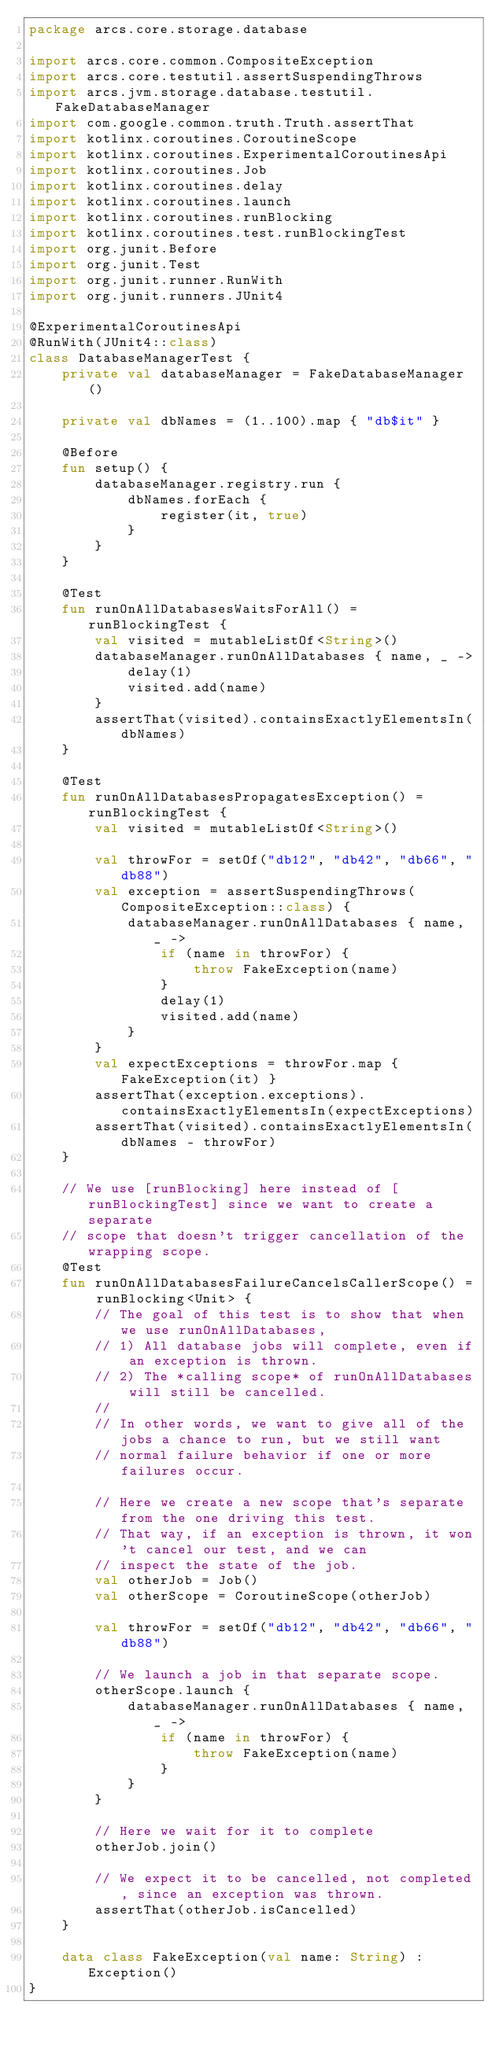<code> <loc_0><loc_0><loc_500><loc_500><_Kotlin_>package arcs.core.storage.database

import arcs.core.common.CompositeException
import arcs.core.testutil.assertSuspendingThrows
import arcs.jvm.storage.database.testutil.FakeDatabaseManager
import com.google.common.truth.Truth.assertThat
import kotlinx.coroutines.CoroutineScope
import kotlinx.coroutines.ExperimentalCoroutinesApi
import kotlinx.coroutines.Job
import kotlinx.coroutines.delay
import kotlinx.coroutines.launch
import kotlinx.coroutines.runBlocking
import kotlinx.coroutines.test.runBlockingTest
import org.junit.Before
import org.junit.Test
import org.junit.runner.RunWith
import org.junit.runners.JUnit4

@ExperimentalCoroutinesApi
@RunWith(JUnit4::class)
class DatabaseManagerTest {
    private val databaseManager = FakeDatabaseManager()

    private val dbNames = (1..100).map { "db$it" }

    @Before
    fun setup() {
        databaseManager.registry.run {
            dbNames.forEach {
                register(it, true)
            }
        }
    }

    @Test
    fun runOnAllDatabasesWaitsForAll() = runBlockingTest {
        val visited = mutableListOf<String>()
        databaseManager.runOnAllDatabases { name, _ ->
            delay(1)
            visited.add(name)
        }
        assertThat(visited).containsExactlyElementsIn(dbNames)
    }

    @Test
    fun runOnAllDatabasesPropagatesException() = runBlockingTest {
        val visited = mutableListOf<String>()

        val throwFor = setOf("db12", "db42", "db66", "db88")
        val exception = assertSuspendingThrows(CompositeException::class) {
            databaseManager.runOnAllDatabases { name, _ ->
                if (name in throwFor) {
                    throw FakeException(name)
                }
                delay(1)
                visited.add(name)
            }
        }
        val expectExceptions = throwFor.map { FakeException(it) }
        assertThat(exception.exceptions).containsExactlyElementsIn(expectExceptions)
        assertThat(visited).containsExactlyElementsIn(dbNames - throwFor)
    }

    // We use [runBlocking] here instead of [runBlockingTest] since we want to create a separate
    // scope that doesn't trigger cancellation of the wrapping scope.
    @Test
    fun runOnAllDatabasesFailureCancelsCallerScope() = runBlocking<Unit> {
        // The goal of this test is to show that when we use runOnAllDatabases,
        // 1) All database jobs will complete, even if an exception is thrown.
        // 2) The *calling scope* of runOnAllDatabases will still be cancelled.
        //
        // In other words, we want to give all of the jobs a chance to run, but we still want
        // normal failure behavior if one or more failures occur.

        // Here we create a new scope that's separate from the one driving this test.
        // That way, if an exception is thrown, it won't cancel our test, and we can
        // inspect the state of the job.
        val otherJob = Job()
        val otherScope = CoroutineScope(otherJob)

        val throwFor = setOf("db12", "db42", "db66", "db88")

        // We launch a job in that separate scope.
        otherScope.launch {
            databaseManager.runOnAllDatabases { name, _ ->
                if (name in throwFor) {
                    throw FakeException(name)
                }
            }
        }

        // Here we wait for it to complete
        otherJob.join()

        // We expect it to be cancelled, not completed, since an exception was thrown.
        assertThat(otherJob.isCancelled)
    }

    data class FakeException(val name: String) : Exception()
}
</code> 